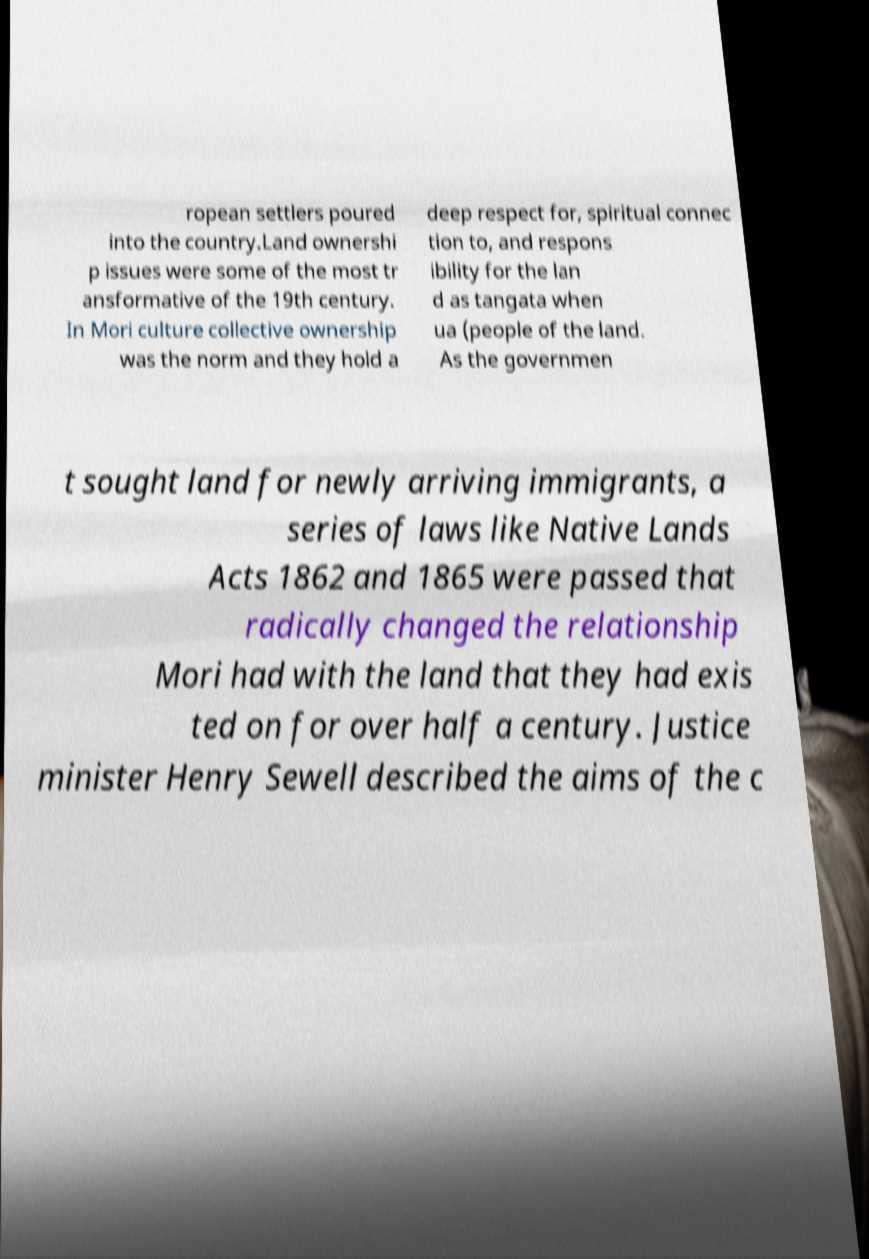Could you assist in decoding the text presented in this image and type it out clearly? ropean settlers poured into the country.Land ownershi p issues were some of the most tr ansformative of the 19th century. In Mori culture collective ownership was the norm and they hold a deep respect for, spiritual connec tion to, and respons ibility for the lan d as tangata when ua (people of the land. As the governmen t sought land for newly arriving immigrants, a series of laws like Native Lands Acts 1862 and 1865 were passed that radically changed the relationship Mori had with the land that they had exis ted on for over half a century. Justice minister Henry Sewell described the aims of the c 